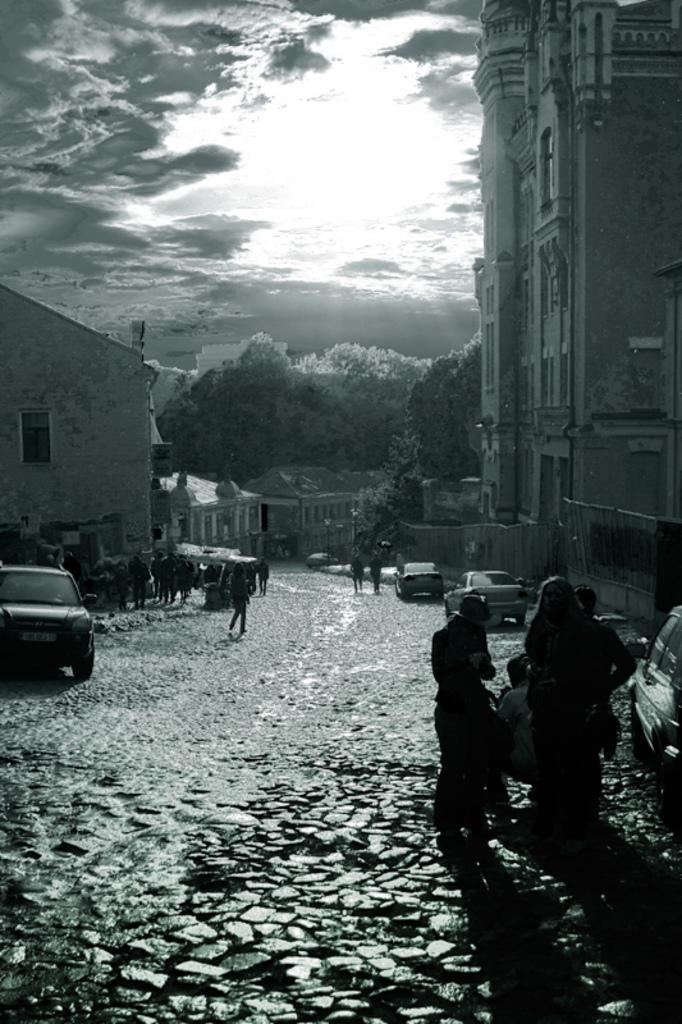What can be seen in the sky in the image? The sky is visible in the image. What type of structures are present in the image? There are buildings in the image. What is happening on the road in the image? There are persons visible on the road, and vehicles are also visible. Can you describe the lighting conditions in the image? The image is very dark. What type of invention is being demonstrated on the bridge in the image? There is no bridge present in the image, and therefore no invention can be observed. What color is the powder being used by the persons in the image? There is no powder present in the image; the persons are simply visible on the road. 